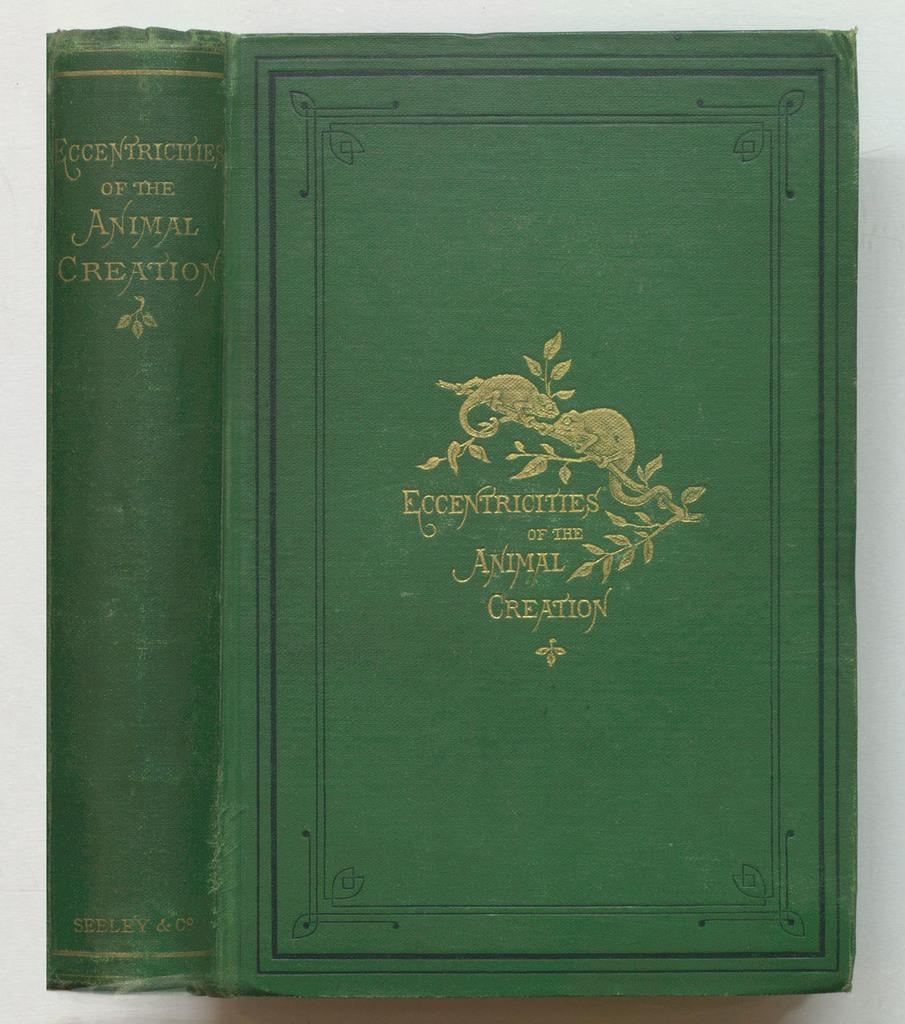<image>
Share a concise interpretation of the image provided. The green cover to the book the eccentricities of the animal creation with an illustration of a horse on the cover. 